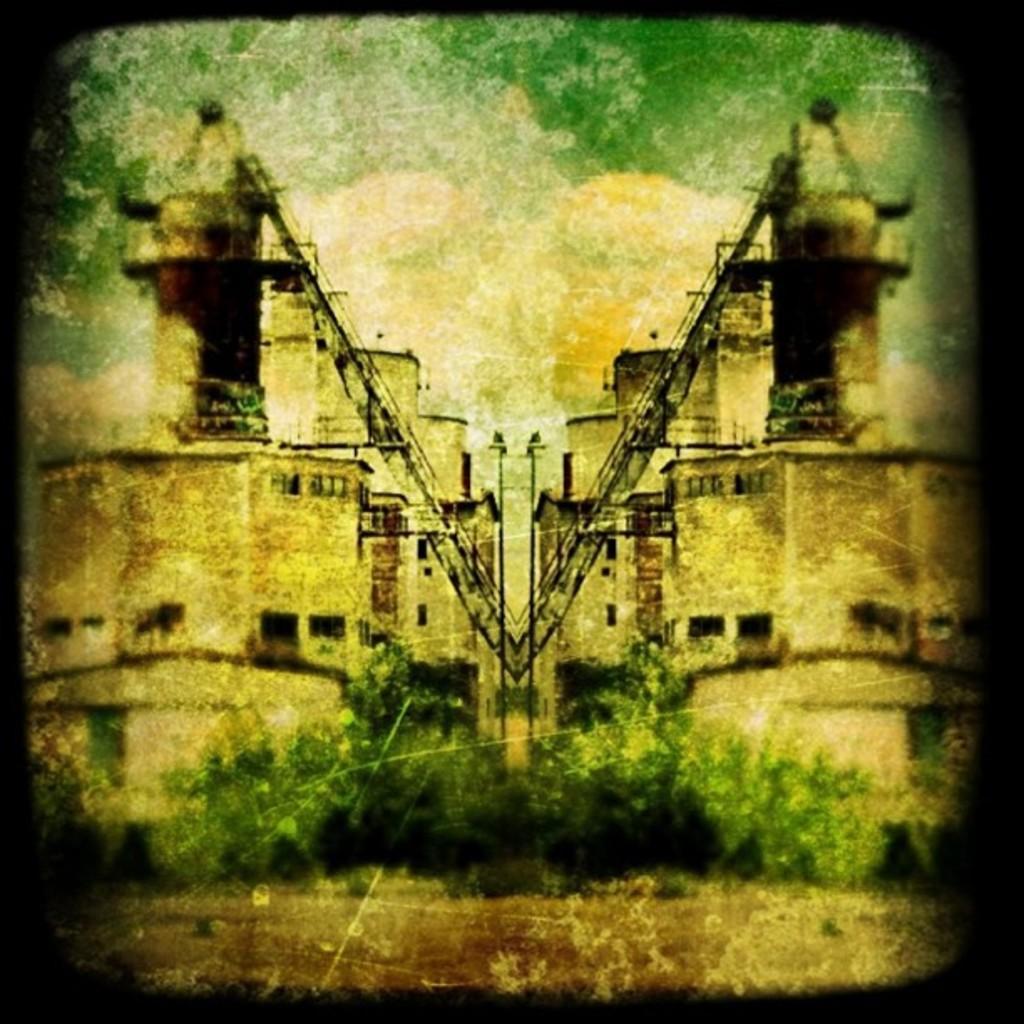How would you summarize this image in a sentence or two? In this image I can see the old photograph in which I can see the ground, few trees which are green in color, few buildings and the sky. 